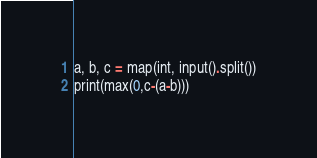<code> <loc_0><loc_0><loc_500><loc_500><_Python_>a, b, c = map(int, input().split())
print(max(0,c-(a-b)))
</code> 